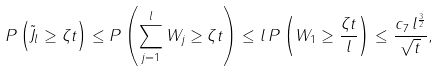<formula> <loc_0><loc_0><loc_500><loc_500>P \left ( \tilde { J } _ { l } \geq \zeta t \right ) \leq P \left ( \sum _ { j = 1 } ^ { l } W _ { j } \geq \zeta t \right ) \leq l \, P \left ( W _ { 1 } \geq \frac { \zeta t } { l } \right ) \leq \frac { c _ { 7 } \, l ^ { \frac { 3 } { 2 } } } { \sqrt { t } } ,</formula> 